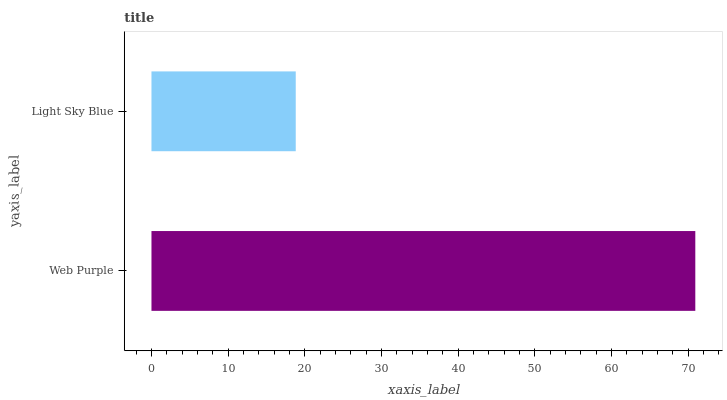Is Light Sky Blue the minimum?
Answer yes or no. Yes. Is Web Purple the maximum?
Answer yes or no. Yes. Is Light Sky Blue the maximum?
Answer yes or no. No. Is Web Purple greater than Light Sky Blue?
Answer yes or no. Yes. Is Light Sky Blue less than Web Purple?
Answer yes or no. Yes. Is Light Sky Blue greater than Web Purple?
Answer yes or no. No. Is Web Purple less than Light Sky Blue?
Answer yes or no. No. Is Web Purple the high median?
Answer yes or no. Yes. Is Light Sky Blue the low median?
Answer yes or no. Yes. Is Light Sky Blue the high median?
Answer yes or no. No. Is Web Purple the low median?
Answer yes or no. No. 